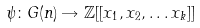Convert formula to latex. <formula><loc_0><loc_0><loc_500><loc_500>\psi \colon G ( n ) \rightarrow \mathbb { Z } [ [ x _ { 1 } , x _ { 2 } , \dots x _ { k } ] ]</formula> 